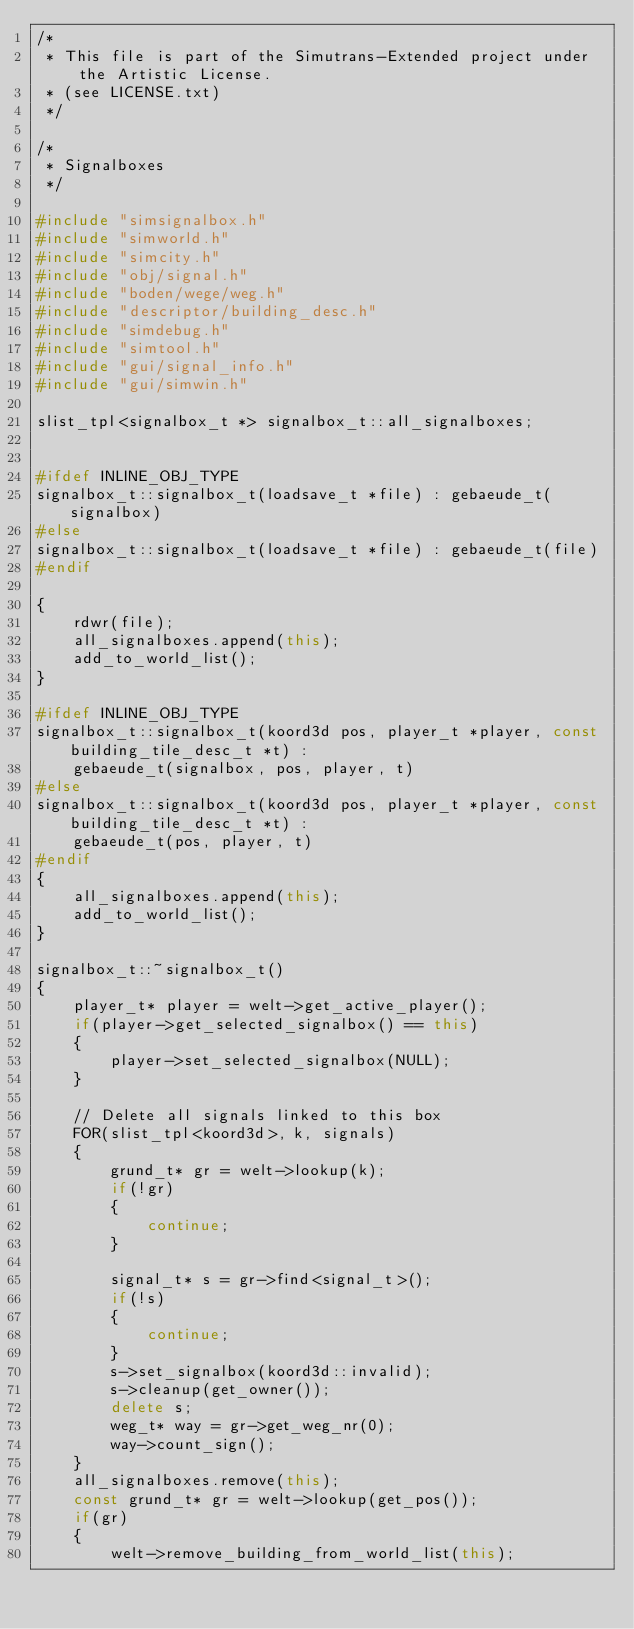Convert code to text. <code><loc_0><loc_0><loc_500><loc_500><_C++_>/*
 * This file is part of the Simutrans-Extended project under the Artistic License.
 * (see LICENSE.txt)
 */

/*
 * Signalboxes
 */

#include "simsignalbox.h"
#include "simworld.h"
#include "simcity.h"
#include "obj/signal.h"
#include "boden/wege/weg.h"
#include "descriptor/building_desc.h"
#include "simdebug.h"
#include "simtool.h"
#include "gui/signal_info.h"
#include "gui/simwin.h"

slist_tpl<signalbox_t *> signalbox_t::all_signalboxes;


#ifdef INLINE_OBJ_TYPE
signalbox_t::signalbox_t(loadsave_t *file) : gebaeude_t(signalbox)
#else
signalbox_t::signalbox_t(loadsave_t *file) : gebaeude_t(file)
#endif

{
	rdwr(file);
	all_signalboxes.append(this);
	add_to_world_list();
}

#ifdef INLINE_OBJ_TYPE
signalbox_t::signalbox_t(koord3d pos, player_t *player, const building_tile_desc_t *t) :
    gebaeude_t(signalbox, pos, player, t)
#else
signalbox_t::signalbox_t(koord3d pos, player_t *player, const building_tile_desc_t *t) :
    gebaeude_t(pos, player, t)
#endif
{
	all_signalboxes.append(this);
	add_to_world_list();
}

signalbox_t::~signalbox_t()
{
	player_t* player = welt->get_active_player();
	if(player->get_selected_signalbox() == this)
	{
		player->set_selected_signalbox(NULL);
	}

	// Delete all signals linked to this box
	FOR(slist_tpl<koord3d>, k, signals)
	{
		grund_t* gr = welt->lookup(k);
		if(!gr)
		{
			continue;
		}

		signal_t* s = gr->find<signal_t>();
		if(!s)
		{
			continue;
		}
		s->set_signalbox(koord3d::invalid);
		s->cleanup(get_owner());
		delete s;
		weg_t* way = gr->get_weg_nr(0);
		way->count_sign();
	}
	all_signalboxes.remove(this);
	const grund_t* gr = welt->lookup(get_pos());
	if(gr)
	{
		welt->remove_building_from_world_list(this);</code> 